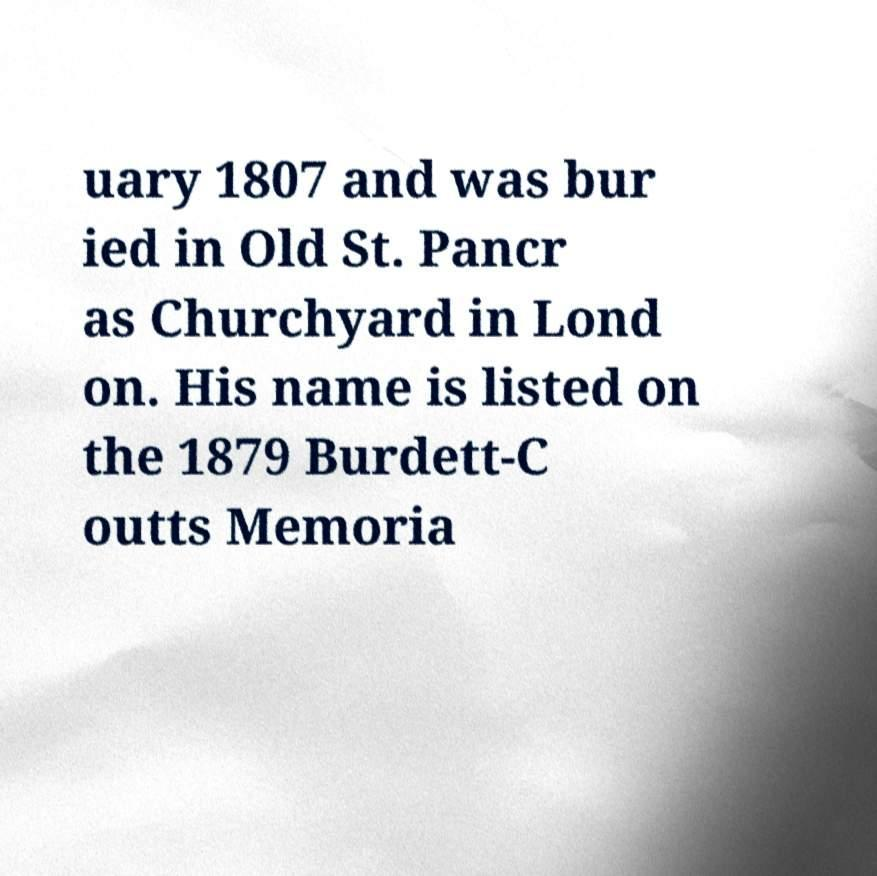Could you extract and type out the text from this image? uary 1807 and was bur ied in Old St. Pancr as Churchyard in Lond on. His name is listed on the 1879 Burdett-C outts Memoria 